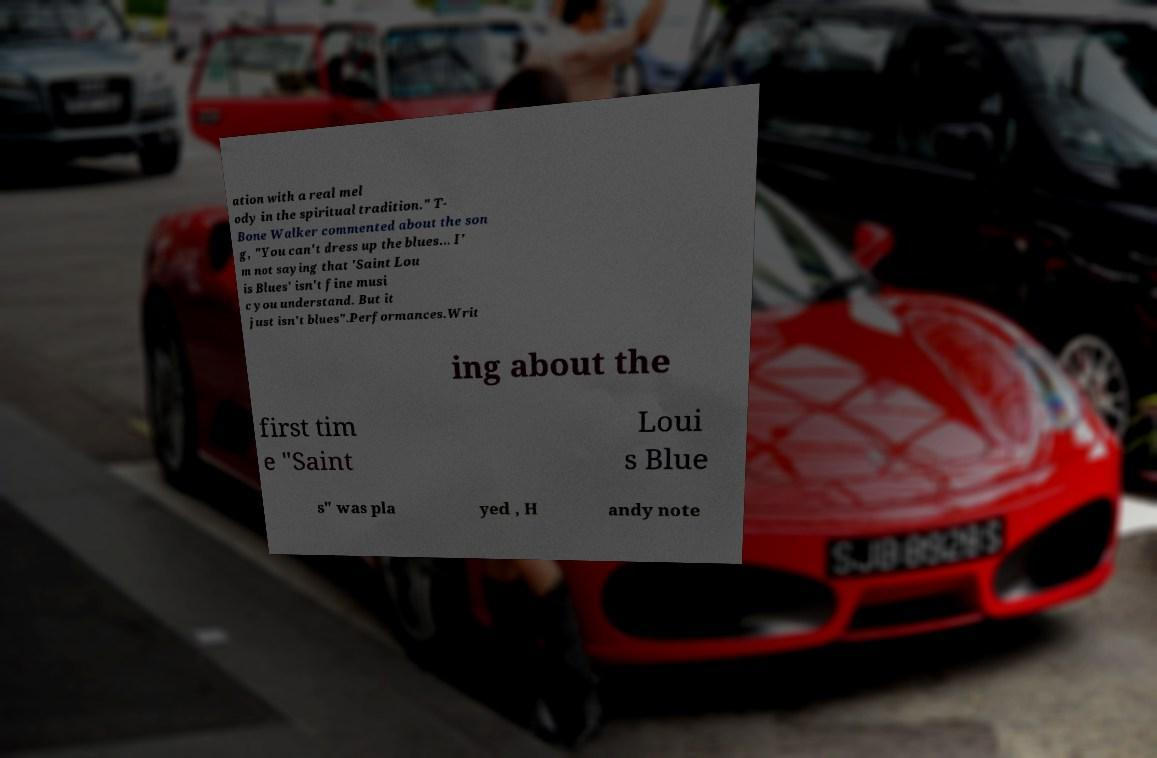Could you assist in decoding the text presented in this image and type it out clearly? ation with a real mel ody in the spiritual tradition." T- Bone Walker commented about the son g, "You can't dress up the blues... I' m not saying that 'Saint Lou is Blues' isn't fine musi c you understand. But it just isn't blues".Performances.Writ ing about the first tim e "Saint Loui s Blue s" was pla yed , H andy note 